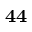<formula> <loc_0><loc_0><loc_500><loc_500>4 4</formula> 